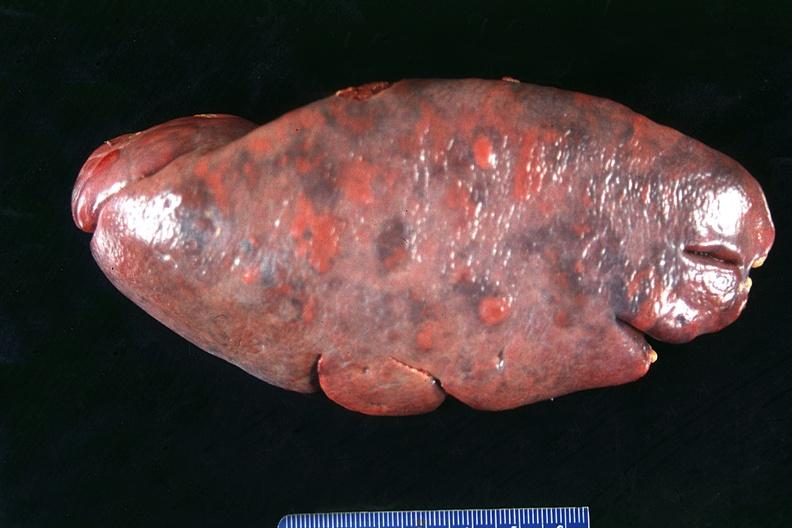what is present?
Answer the question using a single word or phrase. Hematologic 